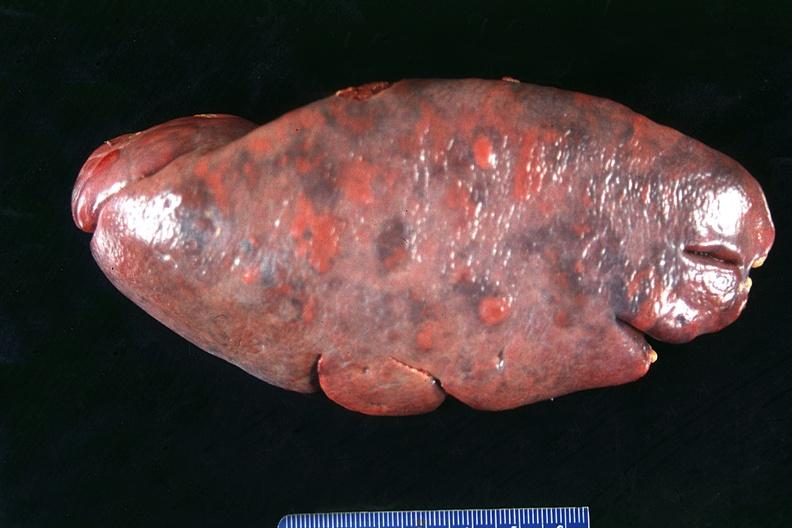what is present?
Answer the question using a single word or phrase. Hematologic 